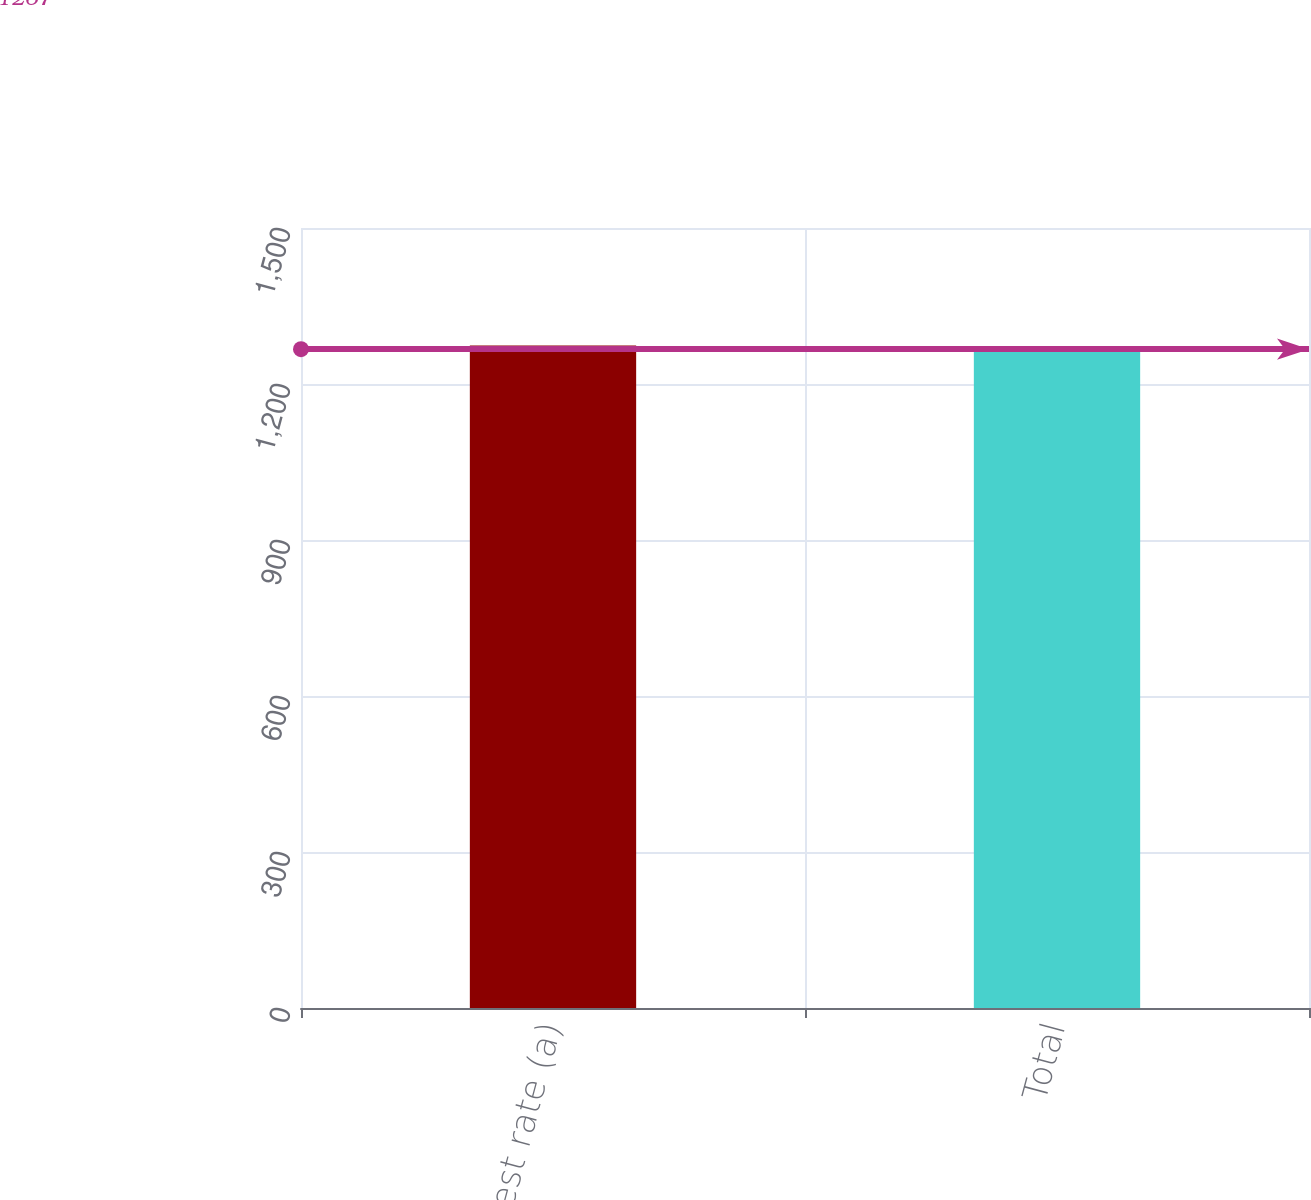Convert chart to OTSL. <chart><loc_0><loc_0><loc_500><loc_500><bar_chart><fcel>Interest rate (a)<fcel>Total<nl><fcel>1274<fcel>1267<nl></chart> 